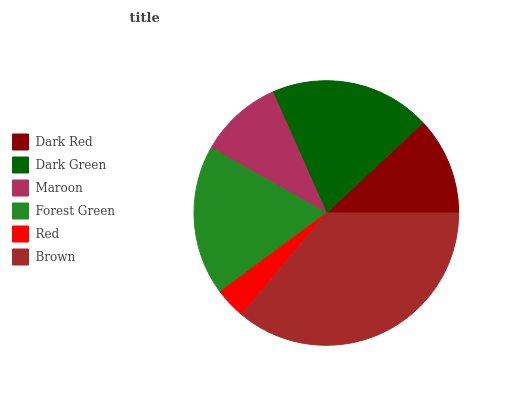Is Red the minimum?
Answer yes or no. Yes. Is Brown the maximum?
Answer yes or no. Yes. Is Dark Green the minimum?
Answer yes or no. No. Is Dark Green the maximum?
Answer yes or no. No. Is Dark Green greater than Dark Red?
Answer yes or no. Yes. Is Dark Red less than Dark Green?
Answer yes or no. Yes. Is Dark Red greater than Dark Green?
Answer yes or no. No. Is Dark Green less than Dark Red?
Answer yes or no. No. Is Forest Green the high median?
Answer yes or no. Yes. Is Dark Red the low median?
Answer yes or no. Yes. Is Maroon the high median?
Answer yes or no. No. Is Dark Green the low median?
Answer yes or no. No. 